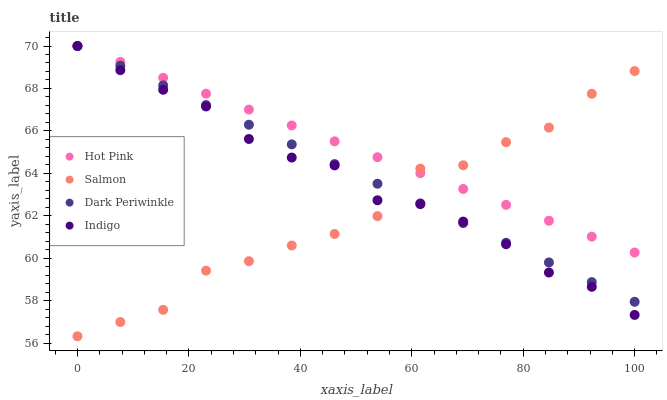Does Salmon have the minimum area under the curve?
Answer yes or no. Yes. Does Hot Pink have the maximum area under the curve?
Answer yes or no. Yes. Does Hot Pink have the minimum area under the curve?
Answer yes or no. No. Does Salmon have the maximum area under the curve?
Answer yes or no. No. Is Dark Periwinkle the smoothest?
Answer yes or no. Yes. Is Salmon the roughest?
Answer yes or no. Yes. Is Hot Pink the smoothest?
Answer yes or no. No. Is Hot Pink the roughest?
Answer yes or no. No. Does Salmon have the lowest value?
Answer yes or no. Yes. Does Hot Pink have the lowest value?
Answer yes or no. No. Does Dark Periwinkle have the highest value?
Answer yes or no. Yes. Does Salmon have the highest value?
Answer yes or no. No. Does Indigo intersect Hot Pink?
Answer yes or no. Yes. Is Indigo less than Hot Pink?
Answer yes or no. No. Is Indigo greater than Hot Pink?
Answer yes or no. No. 